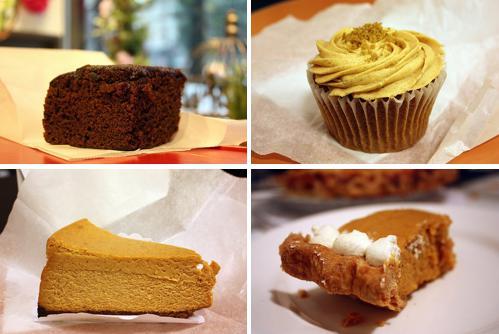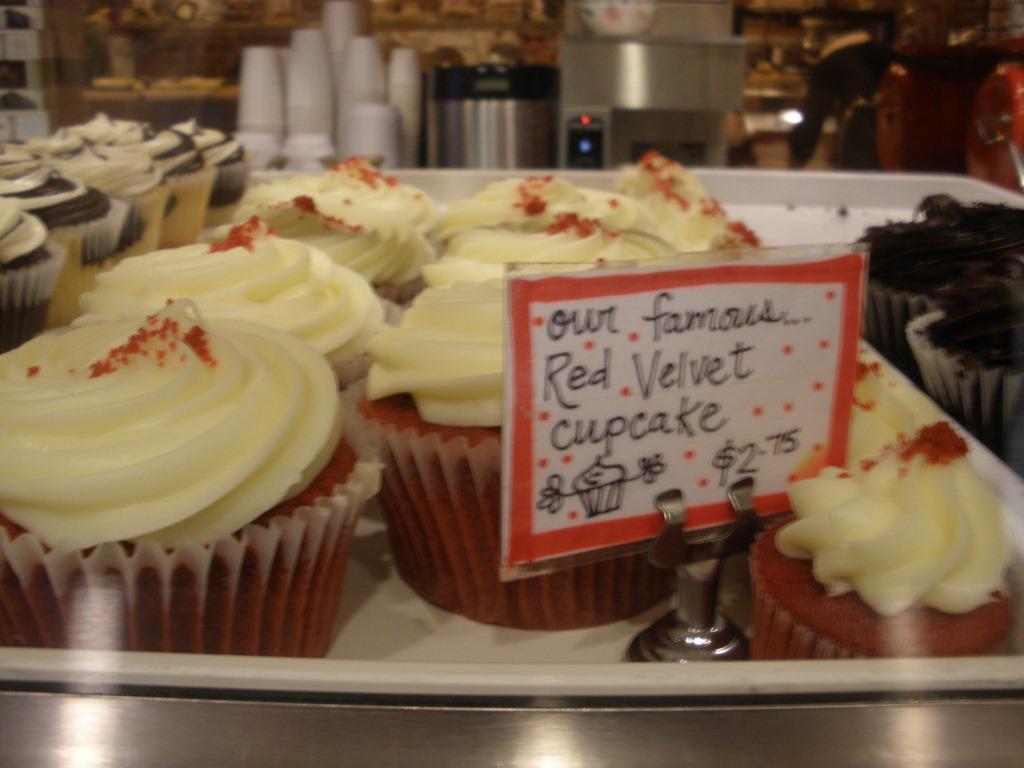The first image is the image on the left, the second image is the image on the right. For the images displayed, is the sentence "There is a human hand reaching for a dessert." factually correct? Answer yes or no. No. 